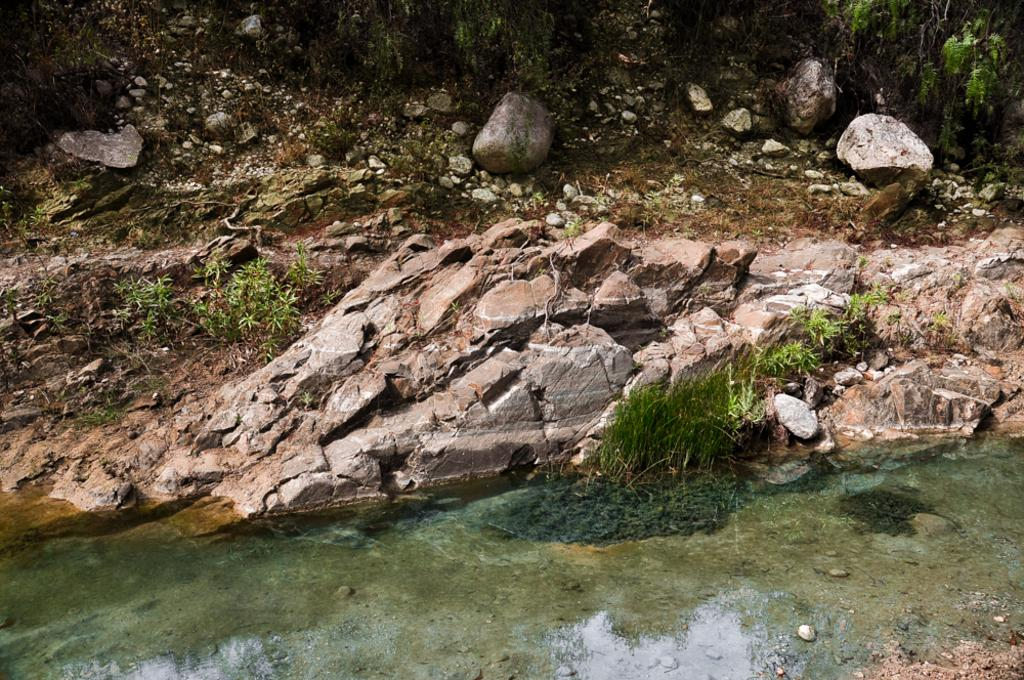What is visible in the image? Water, plants, and trees are visible in the image. What is the color of the plants and trees in the image? The plants and trees are green in color. What can be found in the background of the image? There are stones in the background of the image. How many snails are crawling on the ground in the image? There are no snails visible in the image; it only features water, plants, trees, and stones. 